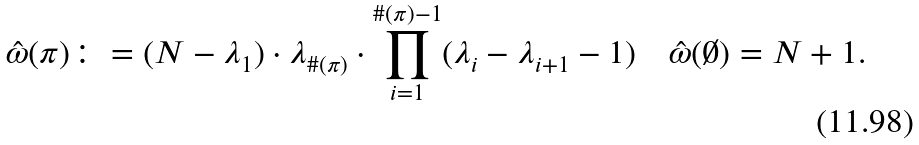Convert formula to latex. <formula><loc_0><loc_0><loc_500><loc_500>\hat { \omega } ( \pi ) \colon = ( N - \lambda _ { 1 } ) \cdot \lambda _ { \# ( \pi ) } \cdot \prod _ { i = 1 } ^ { \# ( \pi ) - 1 } ( \lambda _ { i } - \lambda _ { i + 1 } - 1 ) \quad \hat { \omega } ( \emptyset ) = N + 1 .</formula> 